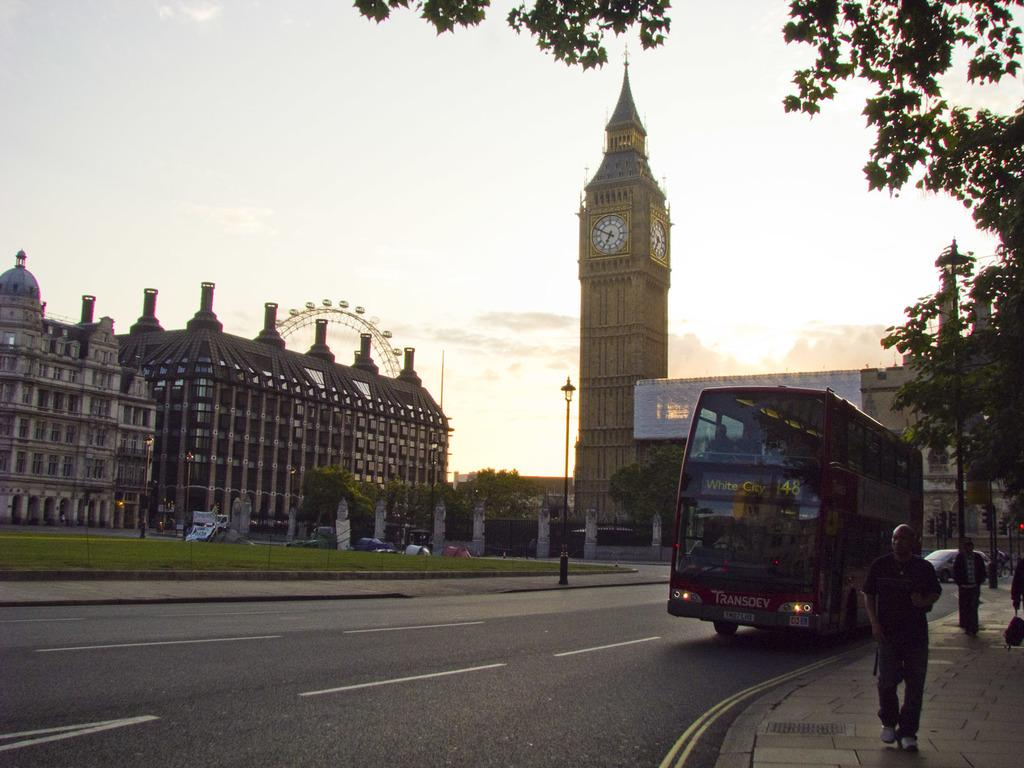<image>
Create a compact narrative representing the image presented. A red London bus infrom of a clock tower the time is 6:50PM 